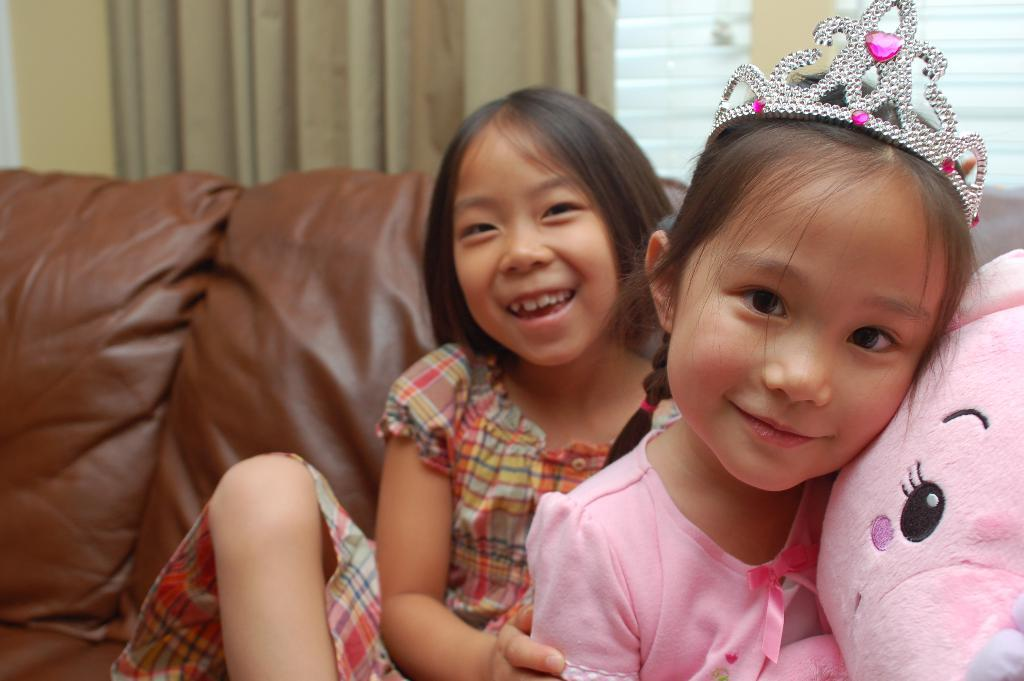Who is present in the image? There are girls in the image. What is the facial expression of the girls? The girls are smiling. What is the girl wearing? The girl is wearing a crown. What object is beside the girl? There is a doll beside the girl. What type of furniture is in the image? There is a sofa in the image. What can be seen in the background of the image? There is a wall, a window, and a curtain associated with the window in the background. What impulse does the toy have in the image? There is no toy present in the image, so it is not possible to determine any impulses. 